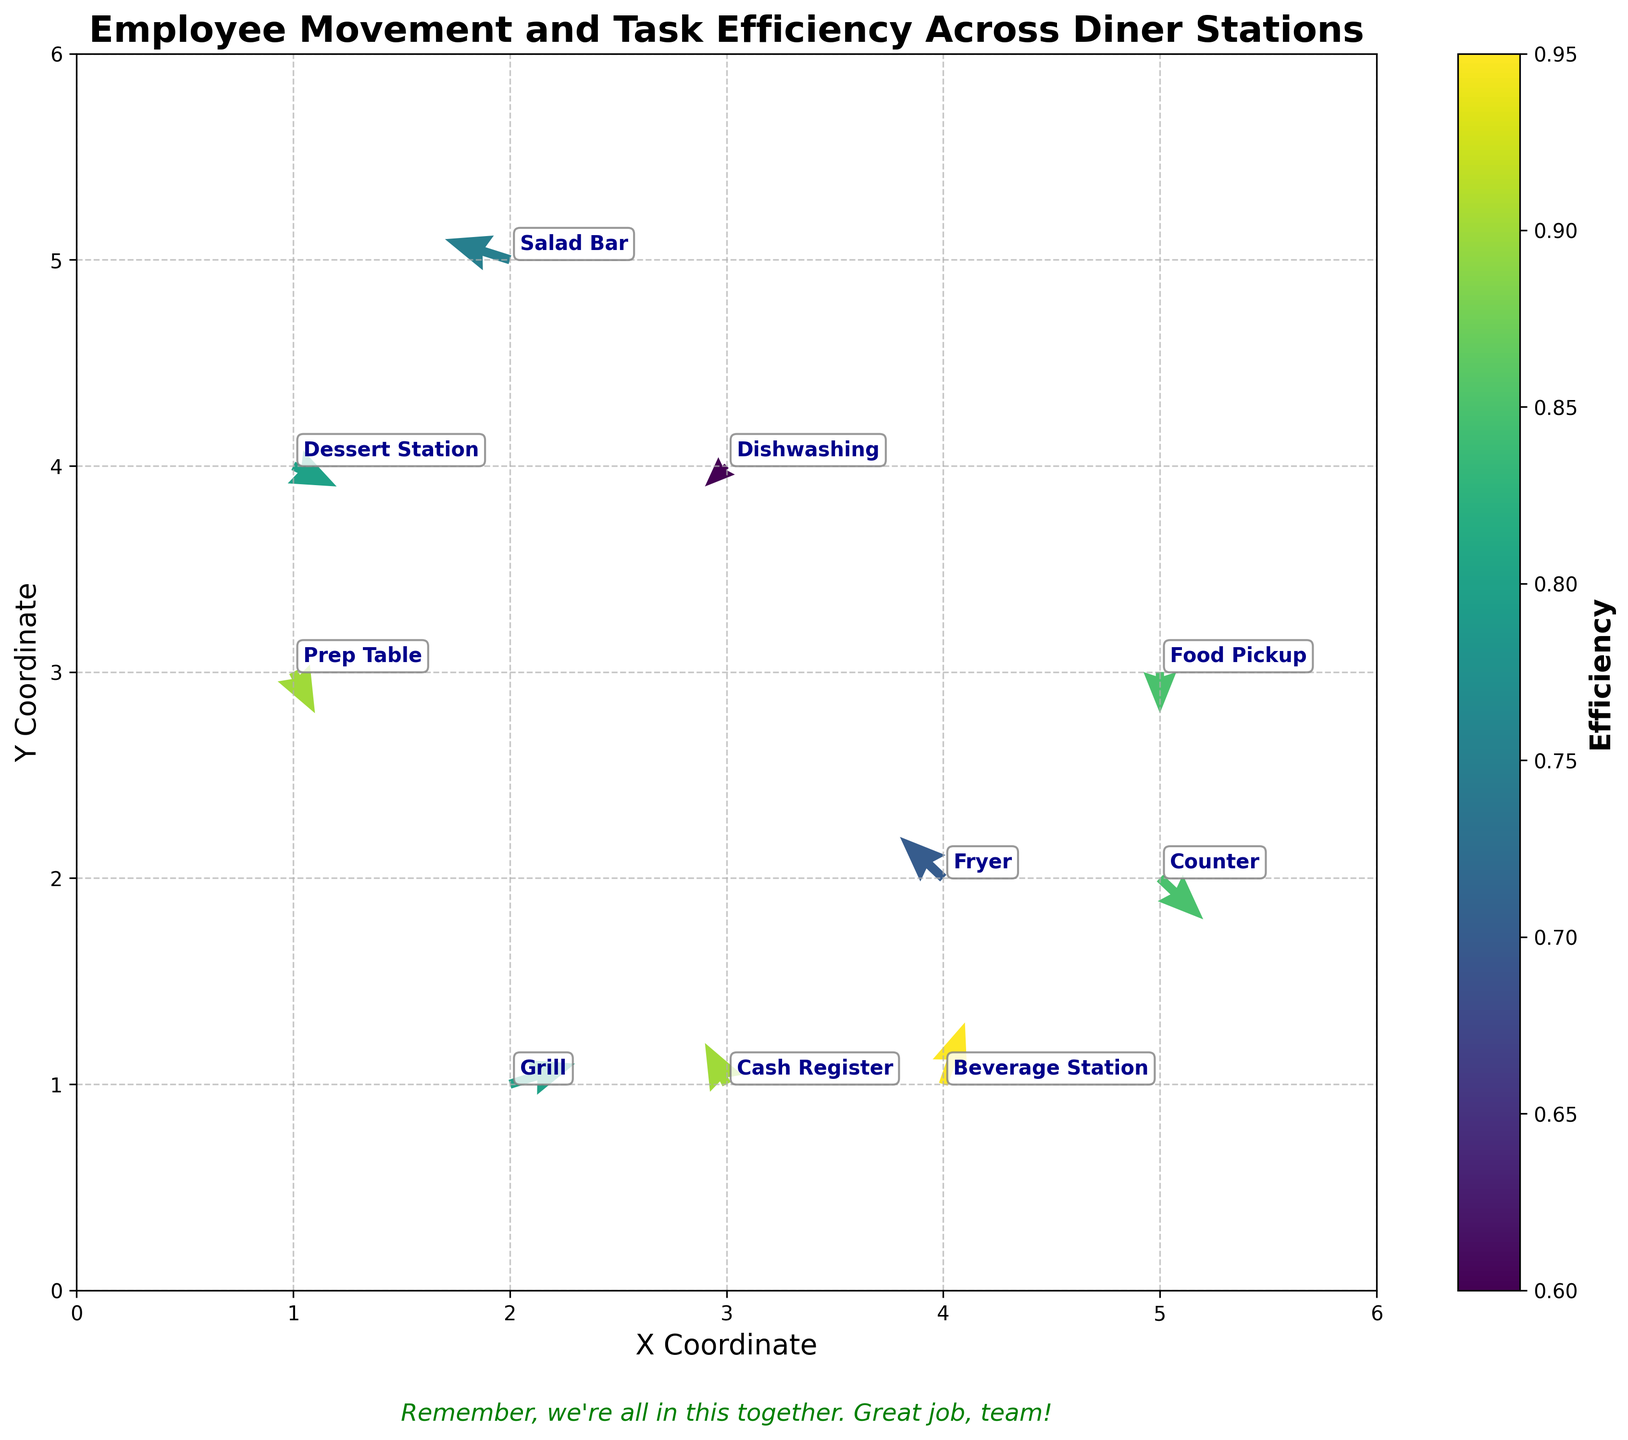What is the title of the plot? The title is usually located at the top of the plot. In this case, it reads "Employee Movement and Task Efficiency Across Diner Stations."
Answer: Employee Movement and Task Efficiency Across Diner Stations What are the axis labels of the plot? Axis labels are placed along the horizontal and vertical axes. Here, the labels are "X Coordinate" on the x-axis and "Y Coordinate" on the y-axis.
Answer: X Coordinate; Y Coordinate Which station has the highest task efficiency? The efficiency values are indicated by the color intensity on the plot. The Beverage Station has the highest efficiency value of 0.95.
Answer: Beverage Station How many stations are shown in the plot? Each station is marked with a label. By counting all the station labels, we have a total of 10 stations.
Answer: 10 Describe the movement vector for the "Grill" station. Each vector represents movement. For the Grill station, located at (2, 1), the vector components are u=1.5 and v=0.5, indicating a movement of 1.5 units to the right and 0.5 units upward.
Answer: (1.5, 0.5) Which station has a downward movement and the lowest task efficiency? Vectors with a downward direction have a negative v component. The Dishwashing station has a downward vector (-0.5, -0.5) and the lowest efficiency value of 0.6.
Answer: Dishwashing Compare the task efficiency of the Cash Register and the Salad Bar. Which one is higher? By checking efficiency values, the Cash Register has an efficiency of 0.9, while the Salad Bar has 0.75. Thus, Cash Register is higher.
Answer: Cash Register What is the average efficiency of the stations in the plot? Calculating the average of the given efficiencies: (0.8 + 0.7 + 0.9 + 0.6 + 0.85 + 0.75 + 0.95 + 0.8 + 0.9 + 0.85) / 10 = 0.81.
Answer: 0.81 Which station demonstrates the largest leftward movement? Leftward movement corresponds to a negative u value. The Salad Bar with u=-1.5 demonstrates the largest leftward movement.
Answer: Salad Bar 